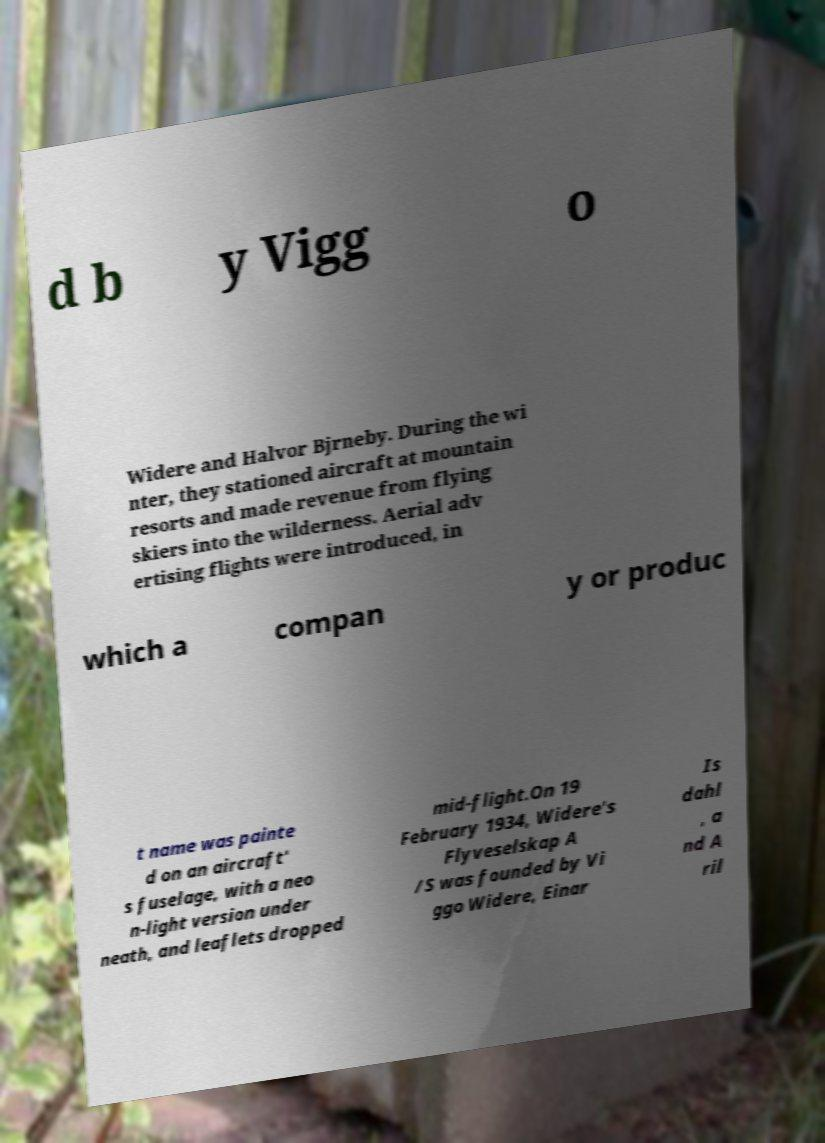Could you assist in decoding the text presented in this image and type it out clearly? d b y Vigg o Widere and Halvor Bjrneby. During the wi nter, they stationed aircraft at mountain resorts and made revenue from flying skiers into the wilderness. Aerial adv ertising flights were introduced, in which a compan y or produc t name was painte d on an aircraft' s fuselage, with a neo n-light version under neath, and leaflets dropped mid-flight.On 19 February 1934, Widere's Flyveselskap A /S was founded by Vi ggo Widere, Einar Is dahl , a nd A ril 